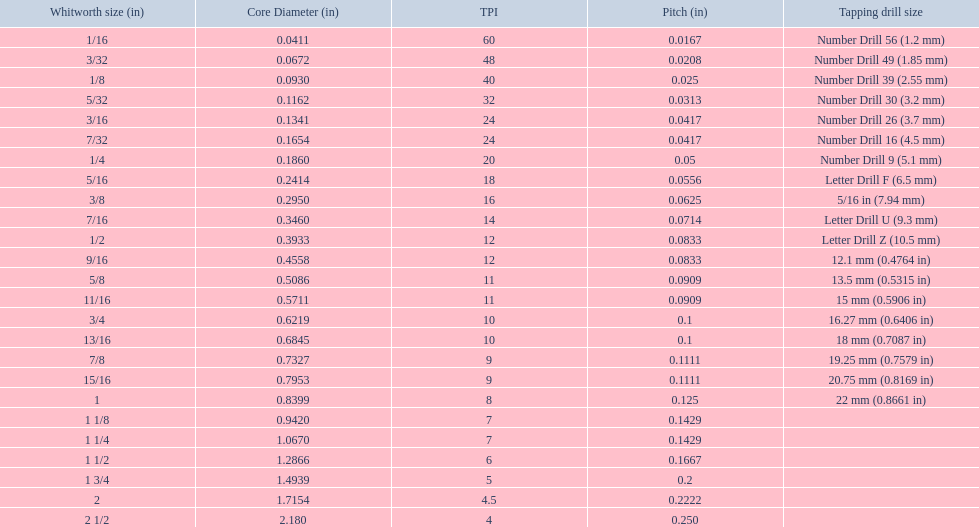A 1/16 whitworth has a core diameter of? 0.0411. Which whiteworth size has the same pitch as a 1/2? 9/16. 3/16 whiteworth has the same number of threads as? 7/32. 